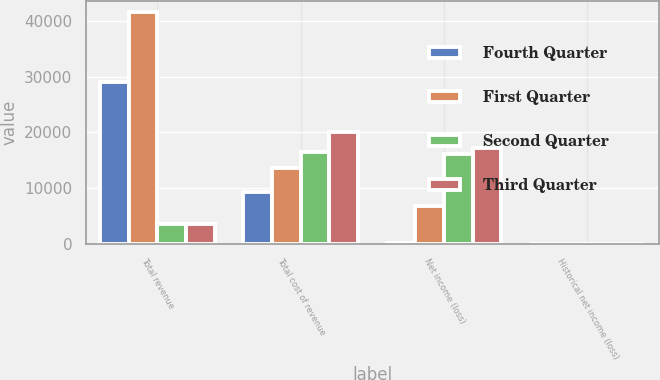<chart> <loc_0><loc_0><loc_500><loc_500><stacked_bar_chart><ecel><fcel>Total revenue<fcel>Total cost of revenue<fcel>Net income (loss)<fcel>Historical net income (loss)<nl><fcel>Fourth Quarter<fcel>29102<fcel>9293<fcel>104<fcel>0<nl><fcel>First Quarter<fcel>41577<fcel>13576<fcel>6768<fcel>0.14<nl><fcel>Second Quarter<fcel>3436<fcel>16356<fcel>16162<fcel>0.32<nl><fcel>Third Quarter<fcel>3436<fcel>20119<fcel>17142<fcel>0.34<nl></chart> 